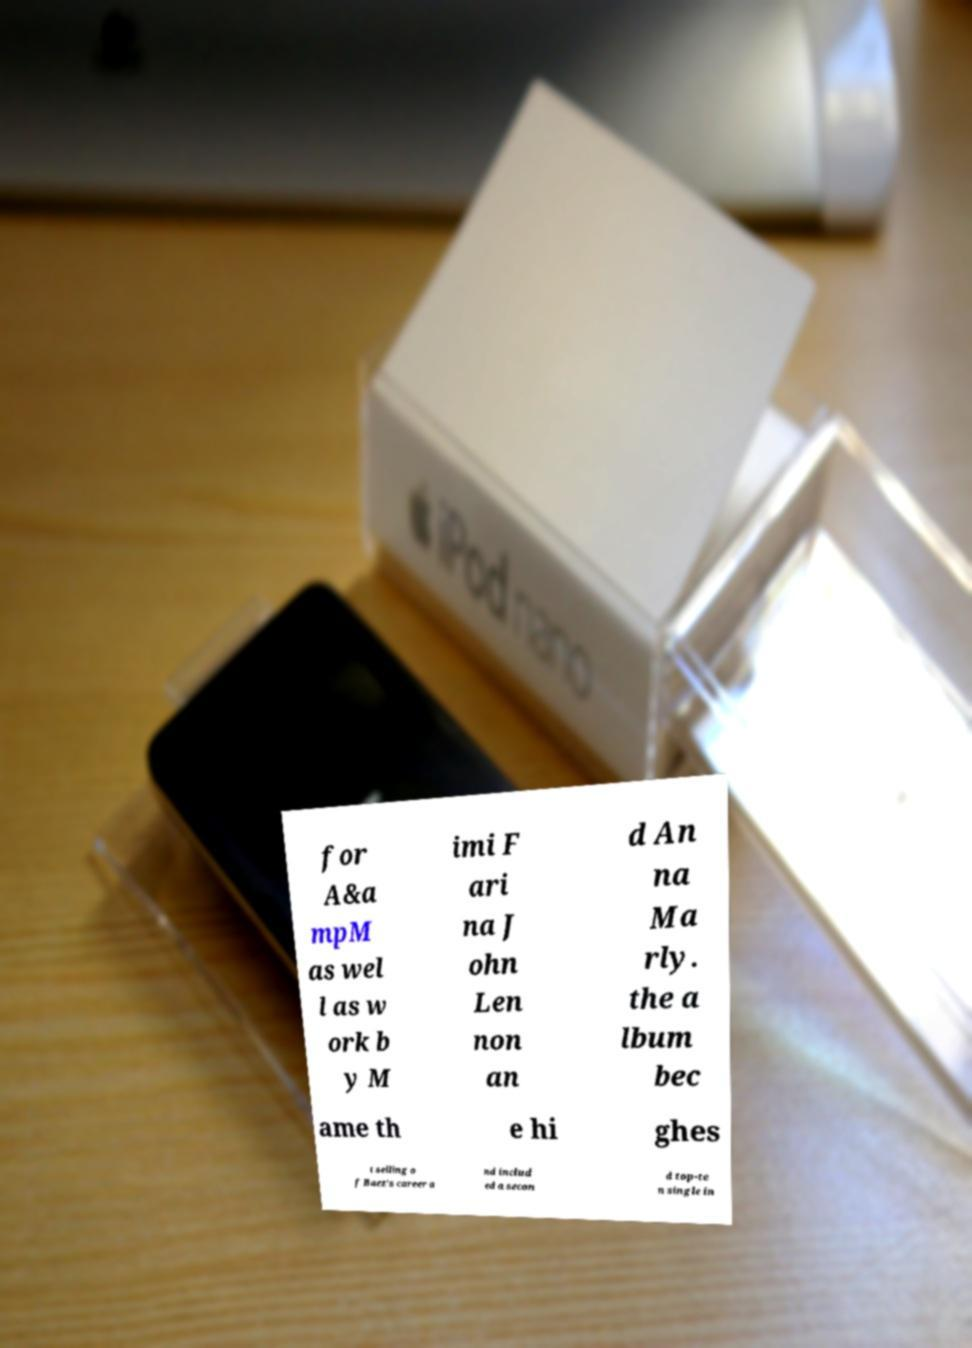Could you assist in decoding the text presented in this image and type it out clearly? for A&a mpM as wel l as w ork b y M imi F ari na J ohn Len non an d An na Ma rly. the a lbum bec ame th e hi ghes t selling o f Baez's career a nd includ ed a secon d top-te n single in 